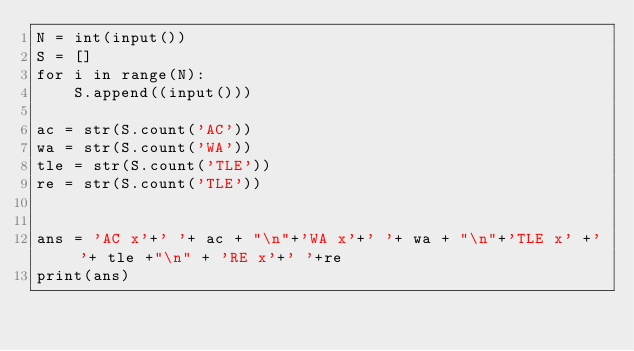<code> <loc_0><loc_0><loc_500><loc_500><_Python_>N = int(input())
S = []
for i in range(N):
    S.append((input()))

ac = str(S.count('AC'))
wa = str(S.count('WA'))
tle = str(S.count('TLE'))
re = str(S.count('TLE'))


ans = 'AC x'+' '+ ac + "\n"+'WA x'+' '+ wa + "\n"+'TLE x' +' '+ tle +"\n" + 'RE x'+' '+re
print(ans)</code> 